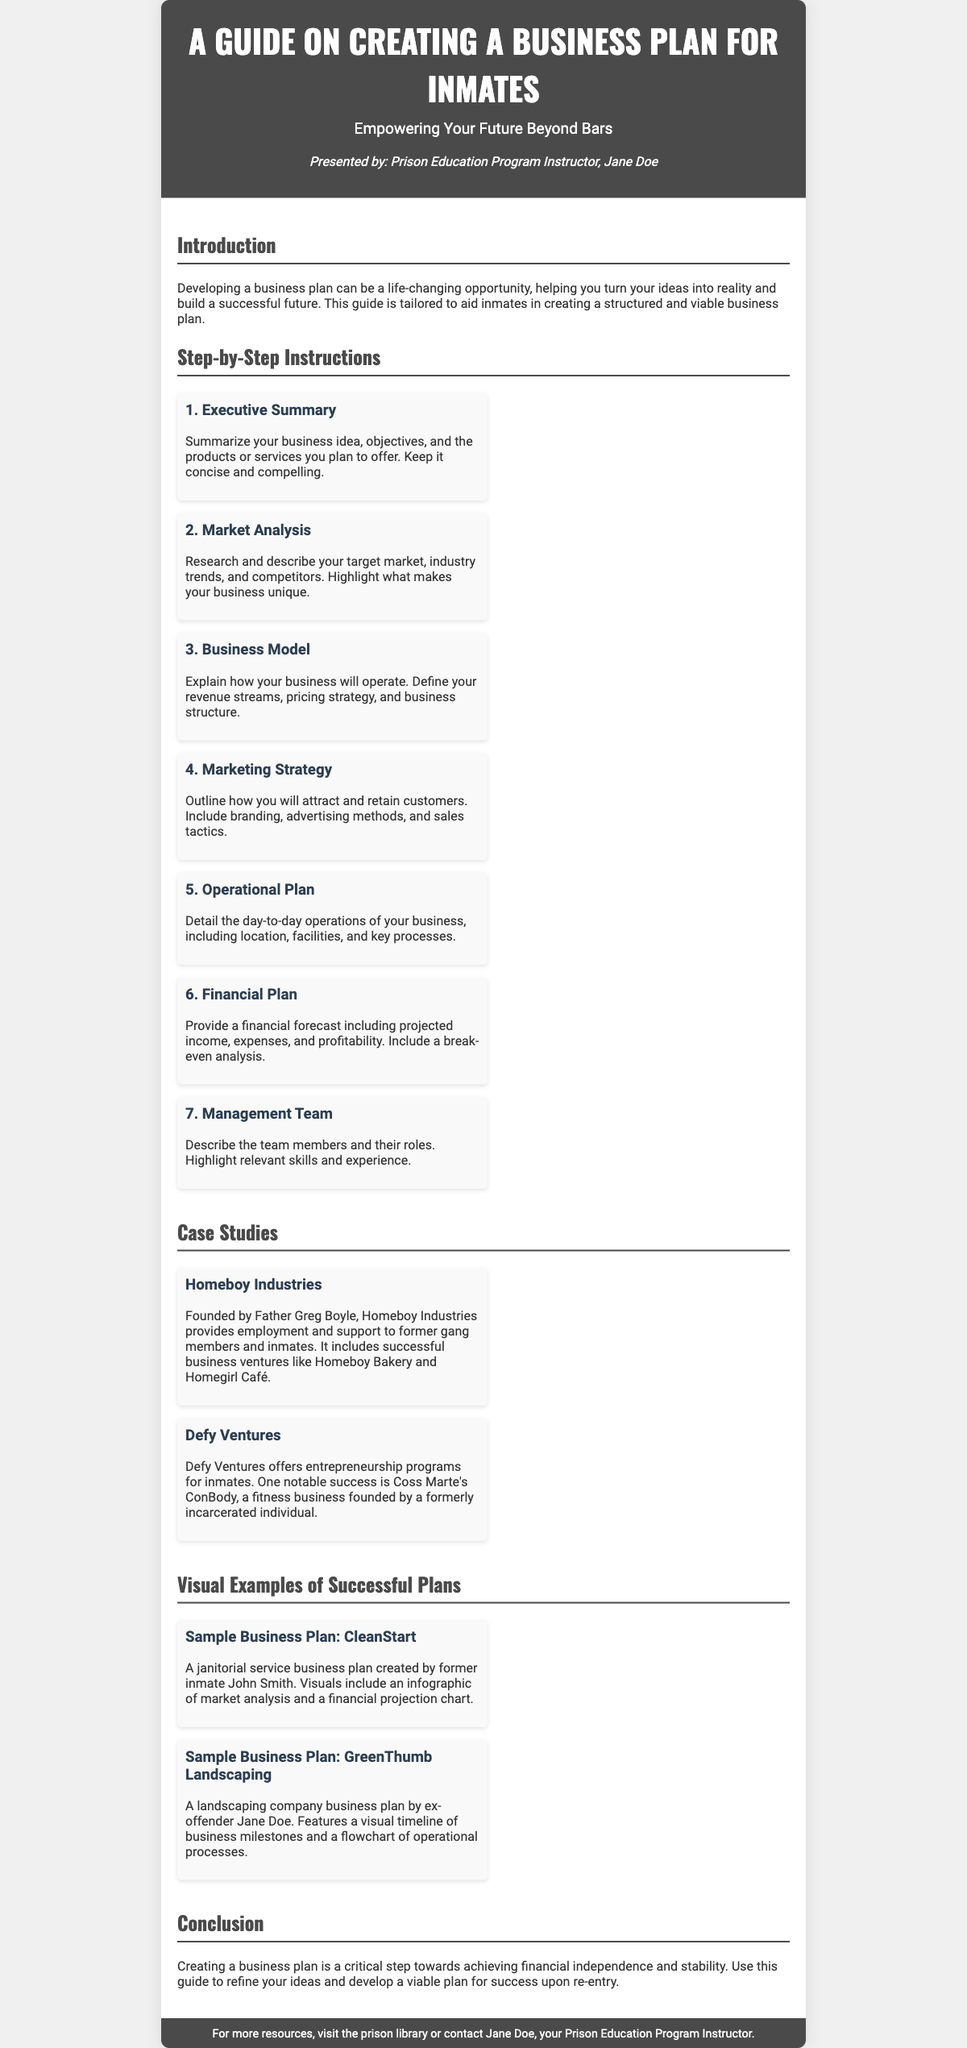What is the title of the guide? The title, prominently displayed at the top of the document, outlines the main subject of the playbill.
Answer: A Guide on Creating a Business Plan for Inmates Who presented the guide? The presenter's name is mentioned in the header section, indicating who is responsible for the guide.
Answer: Jane Doe How many steps are included in the Business Plan instructions? The number of steps can be counted in the "Step-by-Step Instructions" section of the content.
Answer: 7 What is the name of the first case study? The first case study is provided under the "Case Studies" section, detailing a successful organization.
Answer: Homeboy Industries What type of business is CleanStart? The document specifies the nature of the business in the visual example section, describing the service provided.
Answer: Janitorial service What does the "Operational Plan" step detail? This detail can be found in the description under the relevant step within the instructions.
Answer: Day-to-day operations What is highlighted in the financial plan step? The financial plan step contains specific elements that should be included for a comprehensive overview.
Answer: Projected income, expenses, and profitability What is the subtitle of the playbill? The subtitle provides a motivational aspect to the guide and is located just below the title.
Answer: Empowering Your Future Beyond Bars Which business did Coss Marte develop? The document mentions this entrepreneurial venture when describing one of the case studies.
Answer: ConBody 